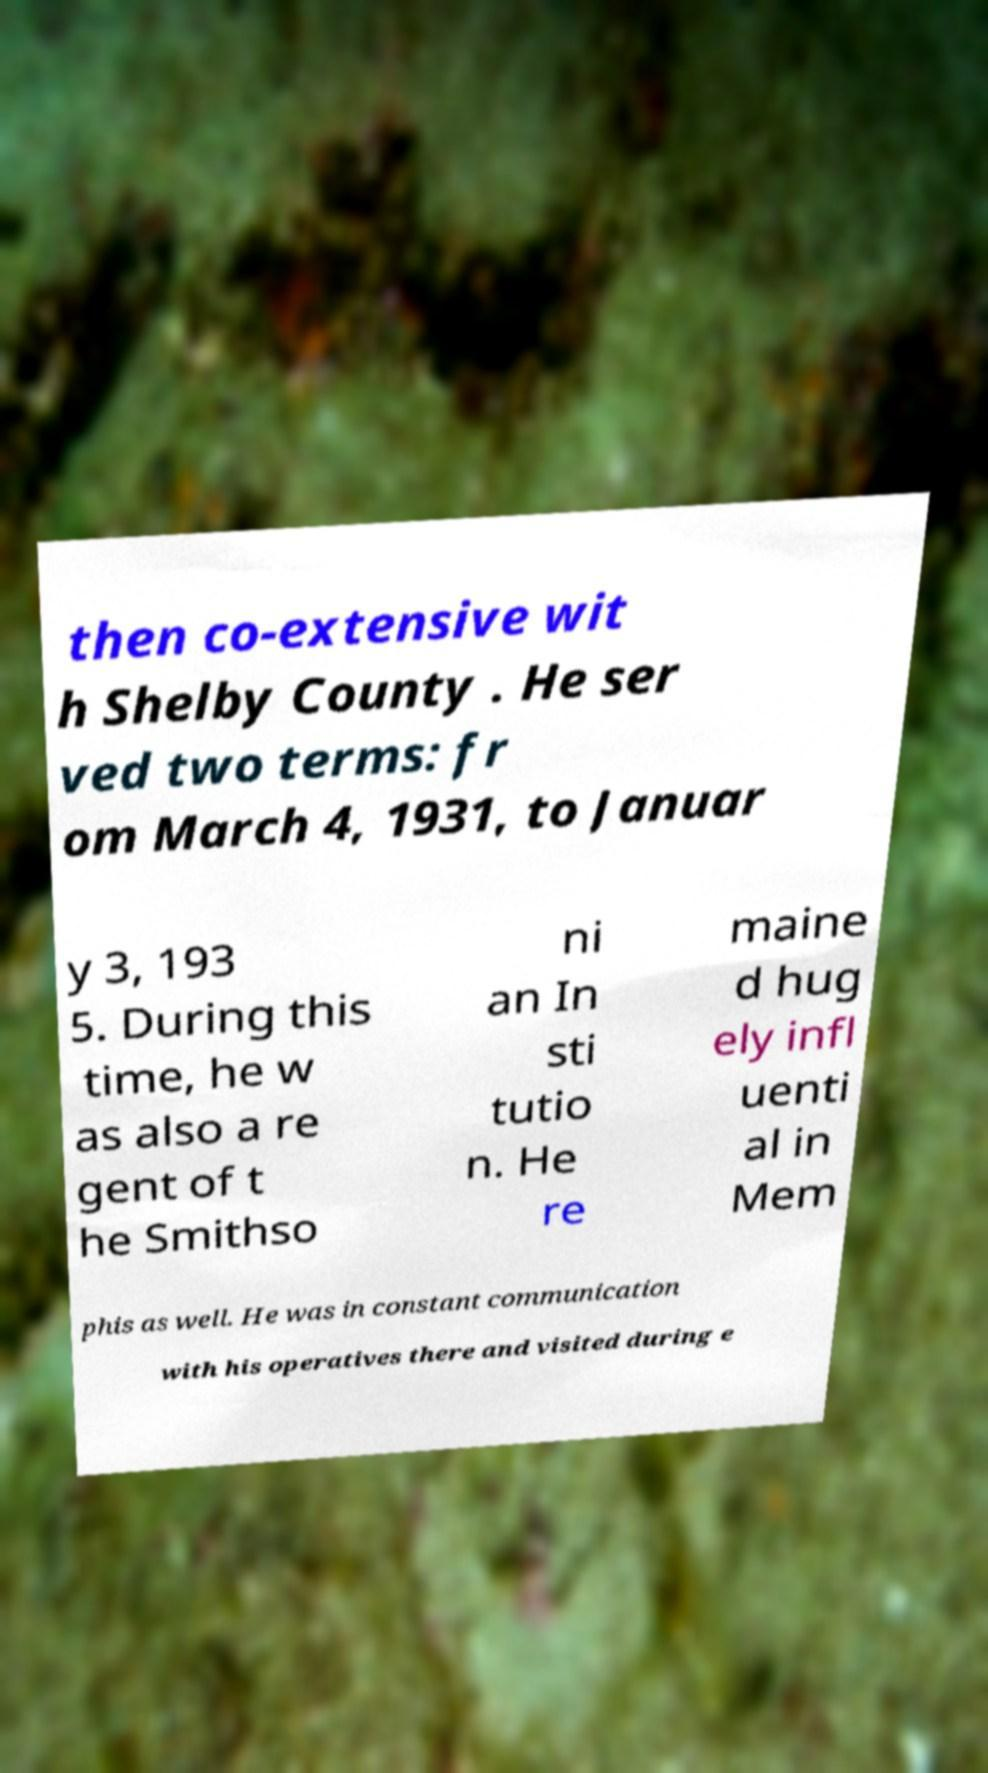Please identify and transcribe the text found in this image. then co-extensive wit h Shelby County . He ser ved two terms: fr om March 4, 1931, to Januar y 3, 193 5. During this time, he w as also a re gent of t he Smithso ni an In sti tutio n. He re maine d hug ely infl uenti al in Mem phis as well. He was in constant communication with his operatives there and visited during e 